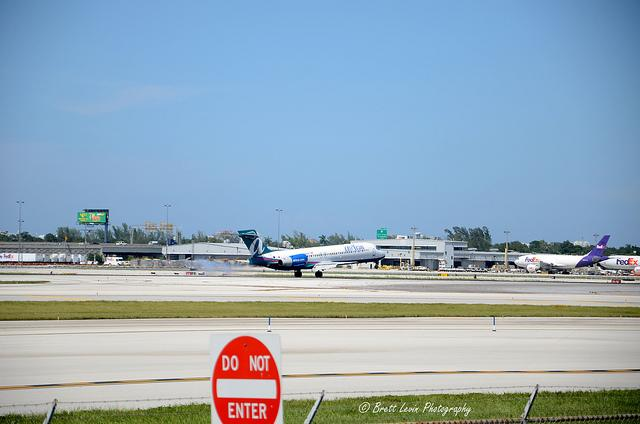What color is the FedEx airplane's tail fin? Please explain your reasoning. purple. Fedex uses purple as their company colors. 